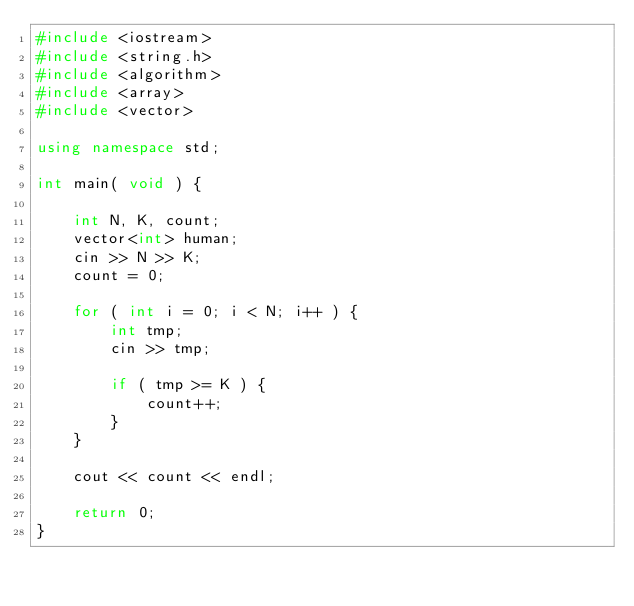<code> <loc_0><loc_0><loc_500><loc_500><_C++_>#include <iostream>
#include <string.h>
#include <algorithm>
#include <array>
#include <vector>

using namespace std;

int main( void ) {

    int N, K, count;
    vector<int> human;
    cin >> N >> K;
    count = 0;

    for ( int i = 0; i < N; i++ ) {
        int tmp;
        cin >> tmp;
        
        if ( tmp >= K ) {
            count++;
        }
    }

    cout << count << endl;

    return 0;   
}</code> 